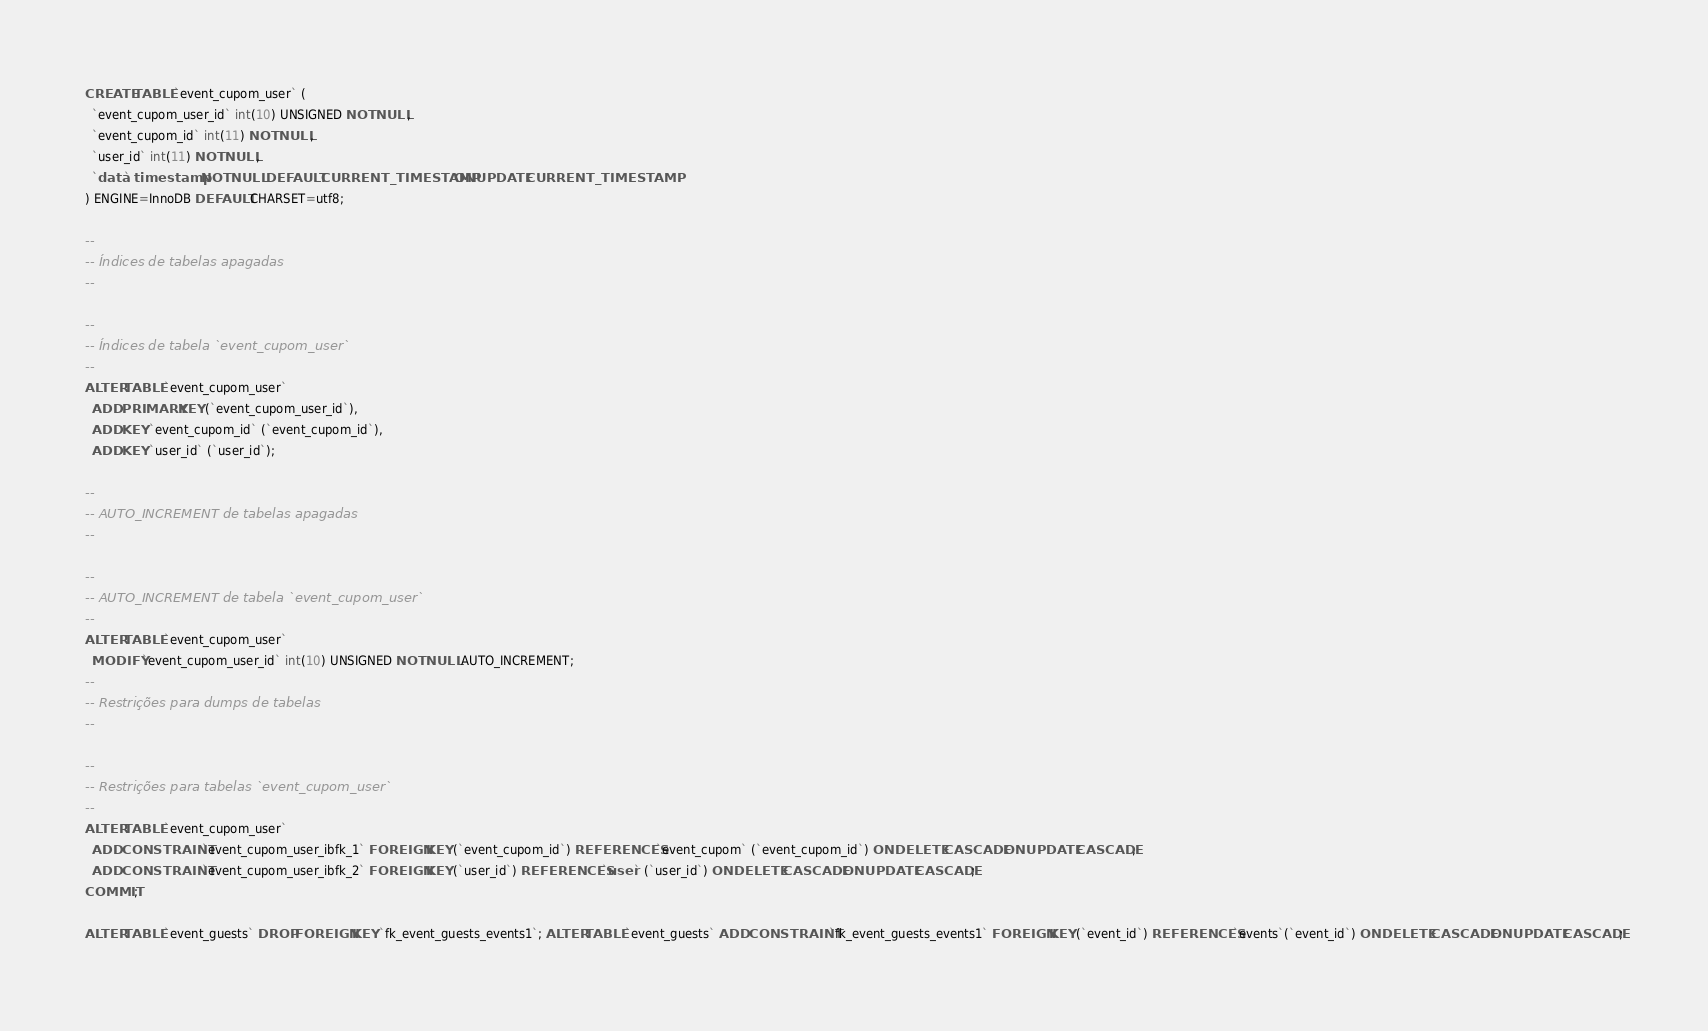Convert code to text. <code><loc_0><loc_0><loc_500><loc_500><_SQL_>
CREATE TABLE `event_cupom_user` (
  `event_cupom_user_id` int(10) UNSIGNED NOT NULL,
  `event_cupom_id` int(11) NOT NULL,
  `user_id` int(11) NOT NULL,
  `data` timestamp NOT NULL DEFAULT CURRENT_TIMESTAMP ON UPDATE CURRENT_TIMESTAMP
) ENGINE=InnoDB DEFAULT CHARSET=utf8;

--
-- Índices de tabelas apagadas
--

--
-- Índices de tabela `event_cupom_user`
--
ALTER TABLE `event_cupom_user`
  ADD PRIMARY KEY (`event_cupom_user_id`),
  ADD KEY `event_cupom_id` (`event_cupom_id`),
  ADD KEY `user_id` (`user_id`);

--
-- AUTO_INCREMENT de tabelas apagadas
--

--
-- AUTO_INCREMENT de tabela `event_cupom_user`
--
ALTER TABLE `event_cupom_user`
  MODIFY `event_cupom_user_id` int(10) UNSIGNED NOT NULL AUTO_INCREMENT;
--
-- Restrições para dumps de tabelas
--

--
-- Restrições para tabelas `event_cupom_user`
--
ALTER TABLE `event_cupom_user`
  ADD CONSTRAINT `event_cupom_user_ibfk_1` FOREIGN KEY (`event_cupom_id`) REFERENCES `event_cupom` (`event_cupom_id`) ON DELETE CASCADE ON UPDATE CASCADE,
  ADD CONSTRAINT `event_cupom_user_ibfk_2` FOREIGN KEY (`user_id`) REFERENCES `user` (`user_id`) ON DELETE CASCADE ON UPDATE CASCADE;
COMMIT;

ALTER TABLE `event_guests` DROP FOREIGN KEY `fk_event_guests_events1`; ALTER TABLE `event_guests` ADD CONSTRAINT `fk_event_guests_events1` FOREIGN KEY (`event_id`) REFERENCES `events`(`event_id`) ON DELETE CASCADE ON UPDATE CASCADE;

</code> 